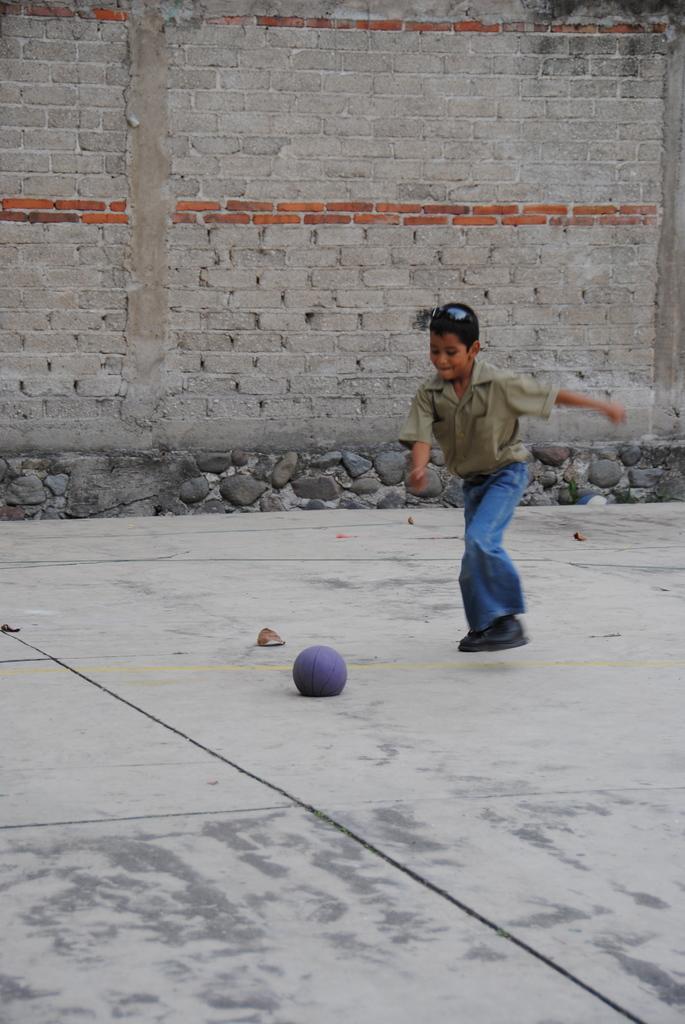In one or two sentences, can you explain what this image depicts? On the right side, there is a boy in jean pant, playing with the ball on a floor. In the background, there is a brick wall. 